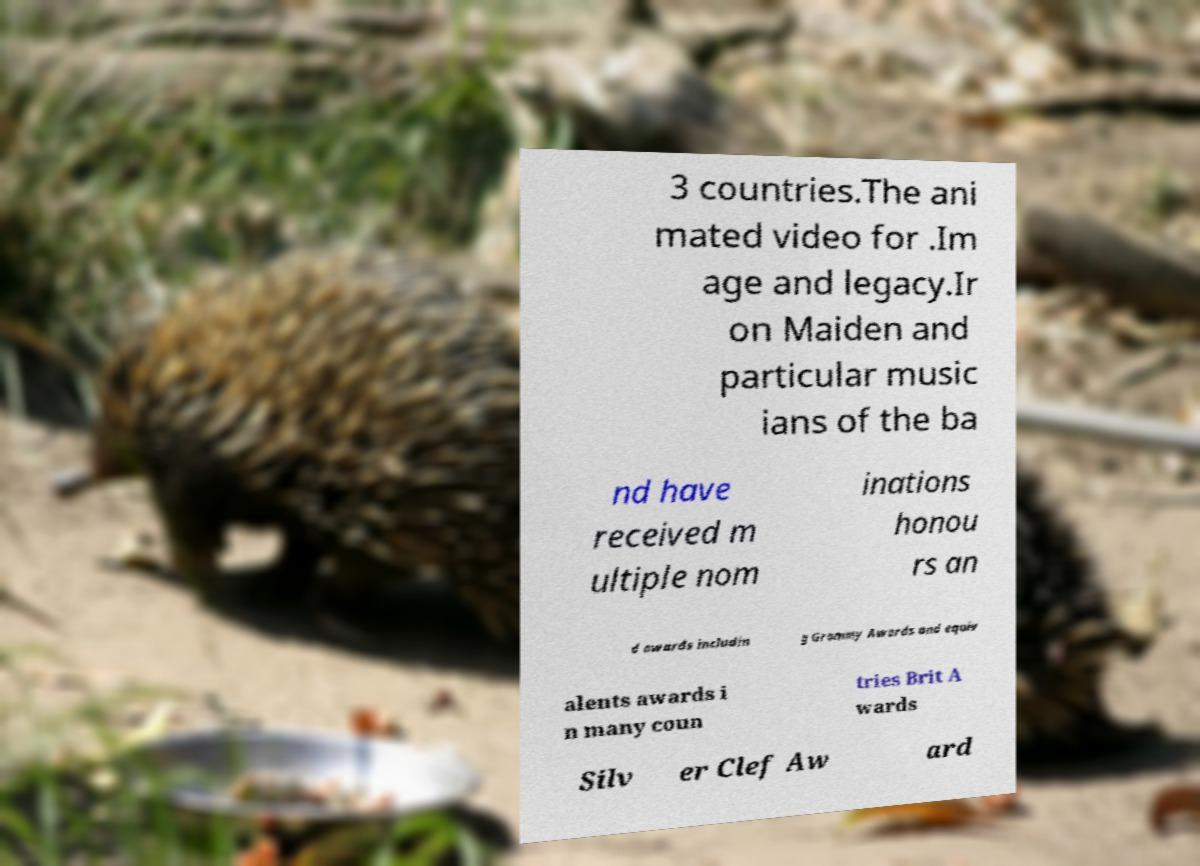There's text embedded in this image that I need extracted. Can you transcribe it verbatim? 3 countries.The ani mated video for .Im age and legacy.Ir on Maiden and particular music ians of the ba nd have received m ultiple nom inations honou rs an d awards includin g Grammy Awards and equiv alents awards i n many coun tries Brit A wards Silv er Clef Aw ard 